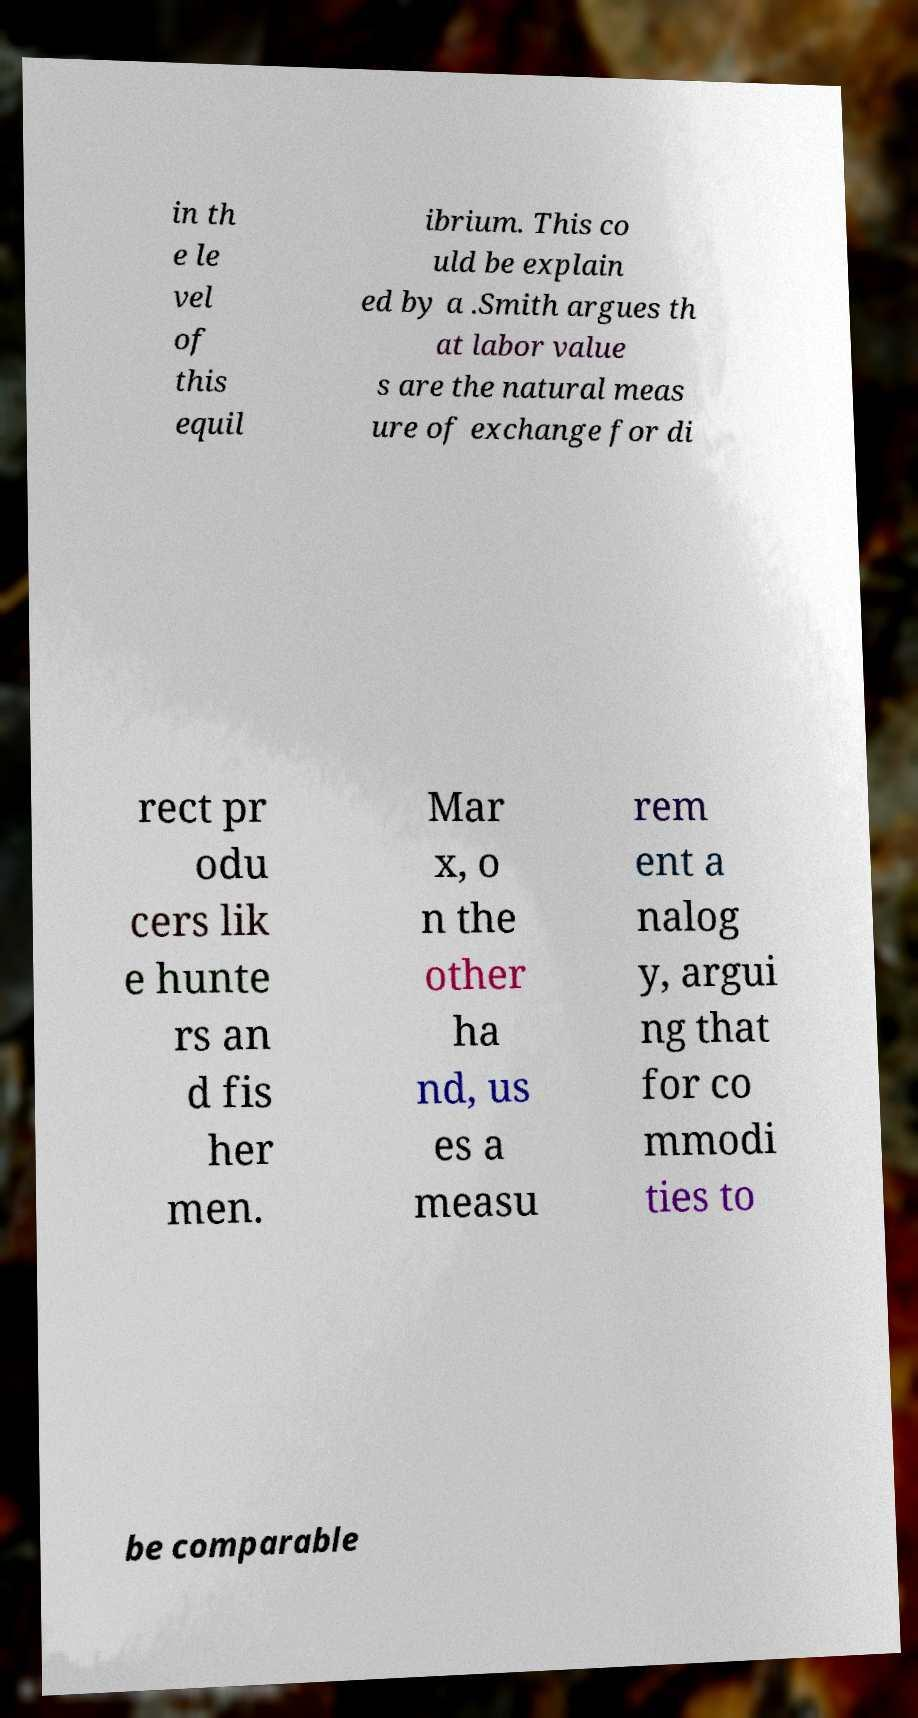What messages or text are displayed in this image? I need them in a readable, typed format. in th e le vel of this equil ibrium. This co uld be explain ed by a .Smith argues th at labor value s are the natural meas ure of exchange for di rect pr odu cers lik e hunte rs an d fis her men. Mar x, o n the other ha nd, us es a measu rem ent a nalog y, argui ng that for co mmodi ties to be comparable 